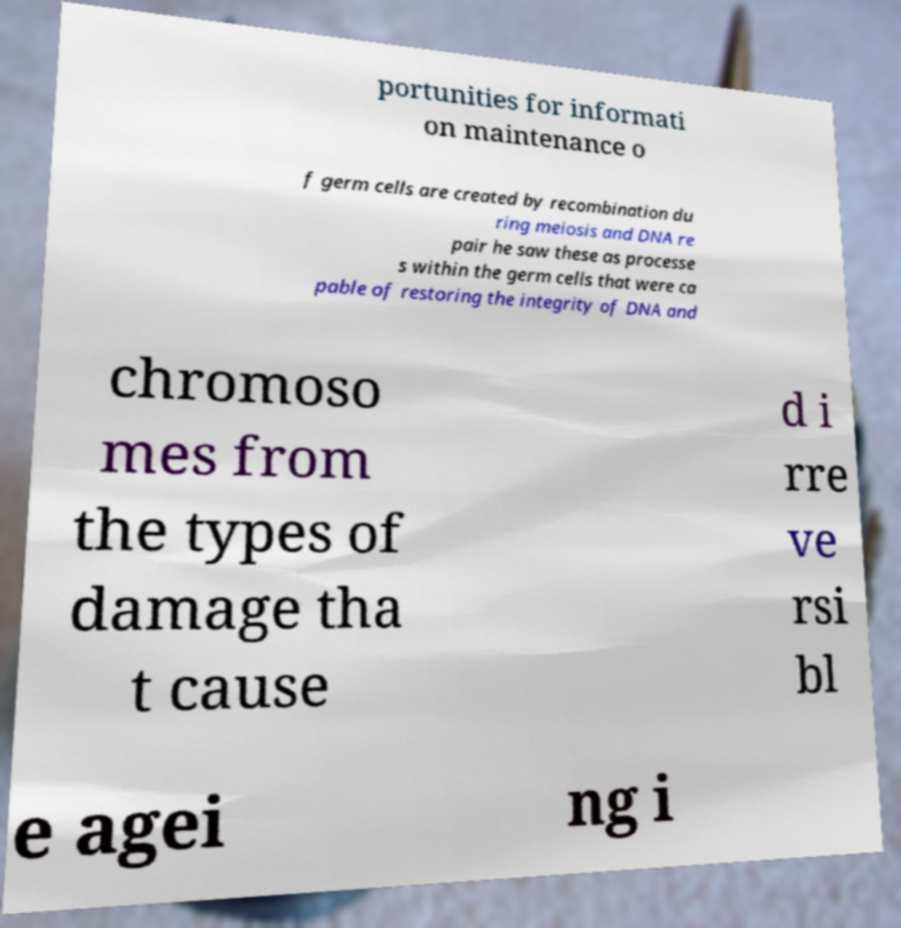Please identify and transcribe the text found in this image. portunities for informati on maintenance o f germ cells are created by recombination du ring meiosis and DNA re pair he saw these as processe s within the germ cells that were ca pable of restoring the integrity of DNA and chromoso mes from the types of damage tha t cause d i rre ve rsi bl e agei ng i 